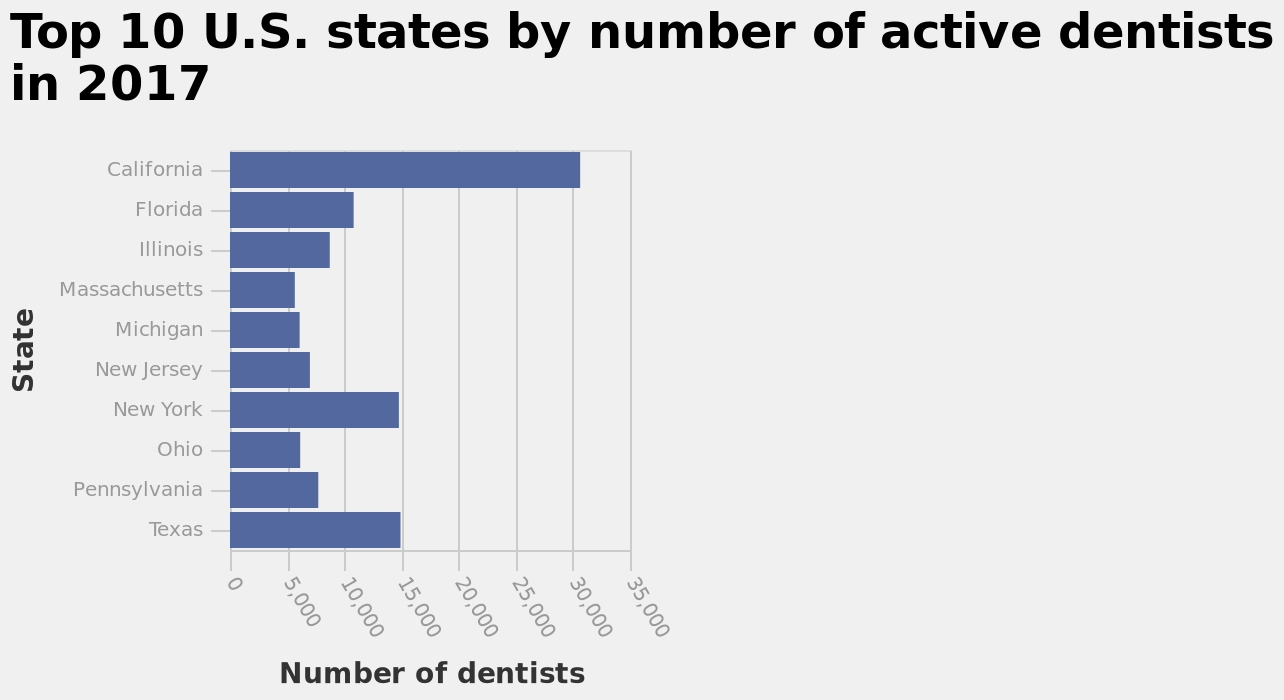<image>
What is the total number of dentists in California, Texas, New York, and Florida combined? Over 40,000 dentists. 